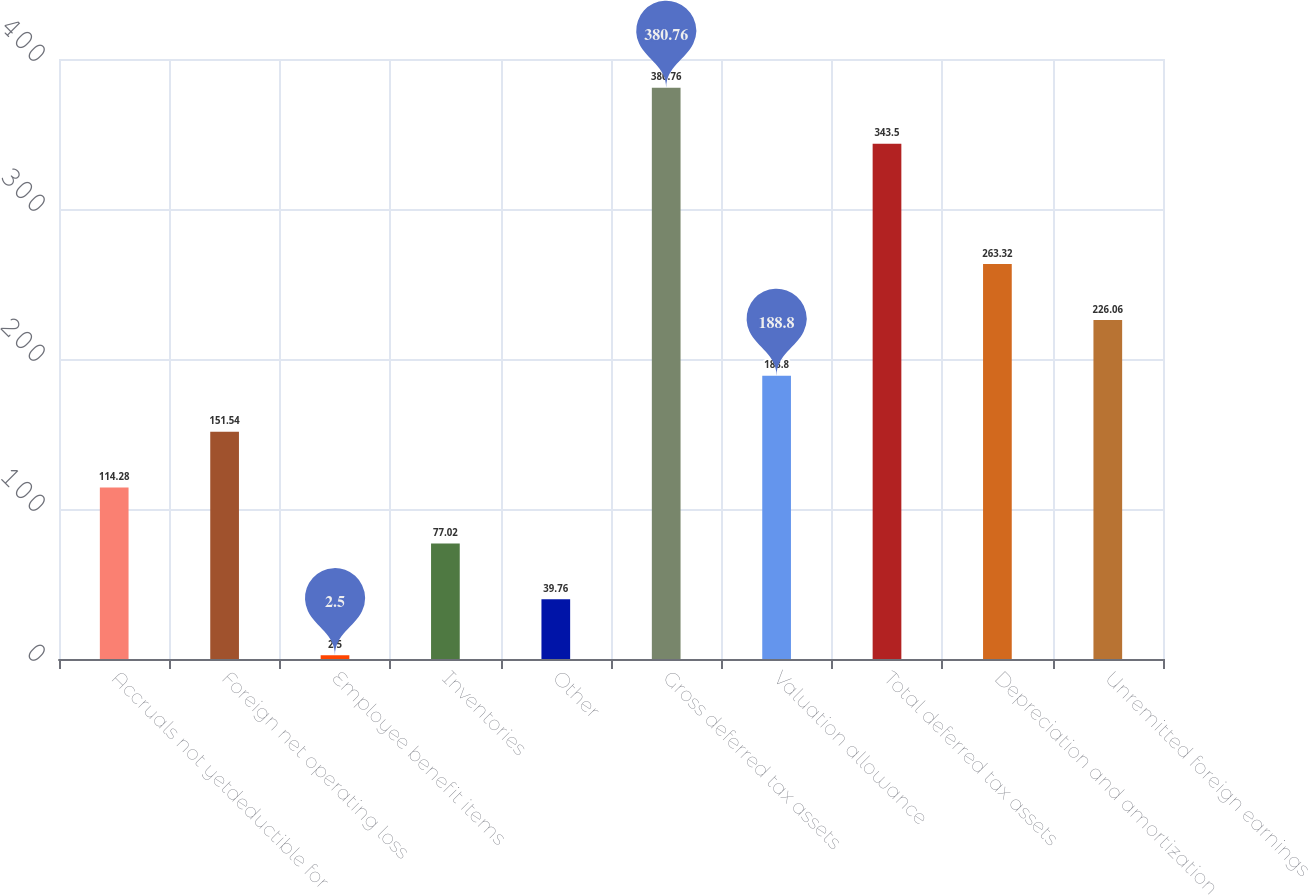Convert chart to OTSL. <chart><loc_0><loc_0><loc_500><loc_500><bar_chart><fcel>Accruals not yetdeductible for<fcel>Foreign net operating loss<fcel>Employee benefit items<fcel>Inventories<fcel>Other<fcel>Gross deferred tax assets<fcel>Valuation allowance<fcel>Total deferred tax assets<fcel>Depreciation and amortization<fcel>Unremitted foreign earnings<nl><fcel>114.28<fcel>151.54<fcel>2.5<fcel>77.02<fcel>39.76<fcel>380.76<fcel>188.8<fcel>343.5<fcel>263.32<fcel>226.06<nl></chart> 